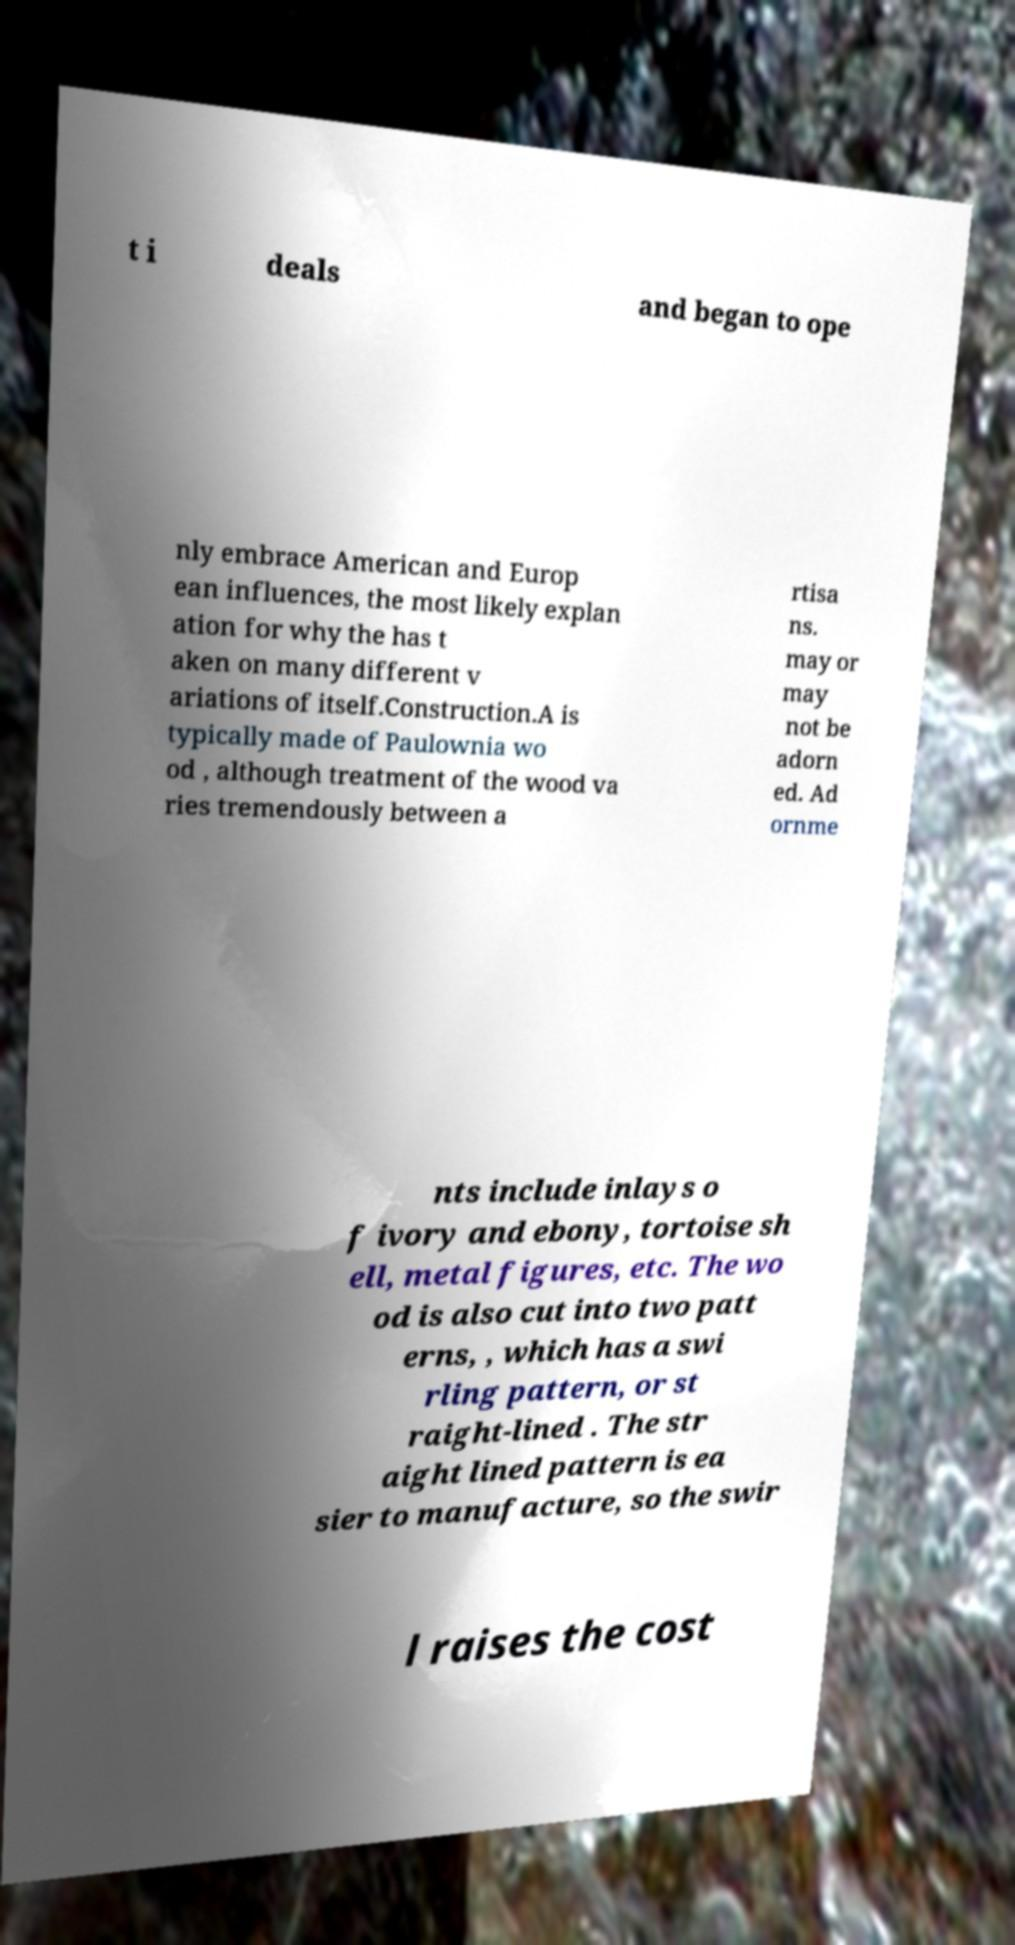I need the written content from this picture converted into text. Can you do that? t i deals and began to ope nly embrace American and Europ ean influences, the most likely explan ation for why the has t aken on many different v ariations of itself.Construction.A is typically made of Paulownia wo od , although treatment of the wood va ries tremendously between a rtisa ns. may or may not be adorn ed. Ad ornme nts include inlays o f ivory and ebony, tortoise sh ell, metal figures, etc. The wo od is also cut into two patt erns, , which has a swi rling pattern, or st raight-lined . The str aight lined pattern is ea sier to manufacture, so the swir l raises the cost 